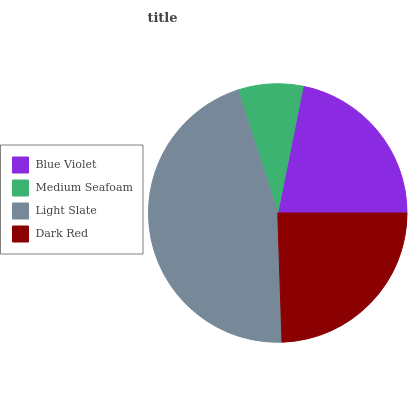Is Medium Seafoam the minimum?
Answer yes or no. Yes. Is Light Slate the maximum?
Answer yes or no. Yes. Is Light Slate the minimum?
Answer yes or no. No. Is Medium Seafoam the maximum?
Answer yes or no. No. Is Light Slate greater than Medium Seafoam?
Answer yes or no. Yes. Is Medium Seafoam less than Light Slate?
Answer yes or no. Yes. Is Medium Seafoam greater than Light Slate?
Answer yes or no. No. Is Light Slate less than Medium Seafoam?
Answer yes or no. No. Is Dark Red the high median?
Answer yes or no. Yes. Is Blue Violet the low median?
Answer yes or no. Yes. Is Blue Violet the high median?
Answer yes or no. No. Is Medium Seafoam the low median?
Answer yes or no. No. 